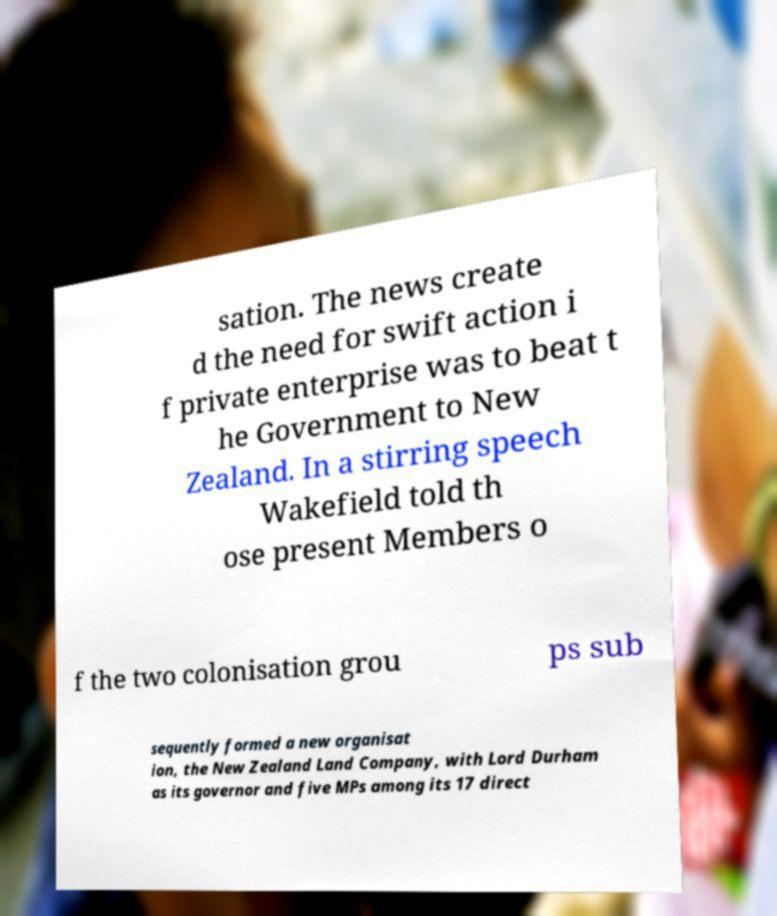What messages or text are displayed in this image? I need them in a readable, typed format. sation. The news create d the need for swift action i f private enterprise was to beat t he Government to New Zealand. In a stirring speech Wakefield told th ose present Members o f the two colonisation grou ps sub sequently formed a new organisat ion, the New Zealand Land Company, with Lord Durham as its governor and five MPs among its 17 direct 